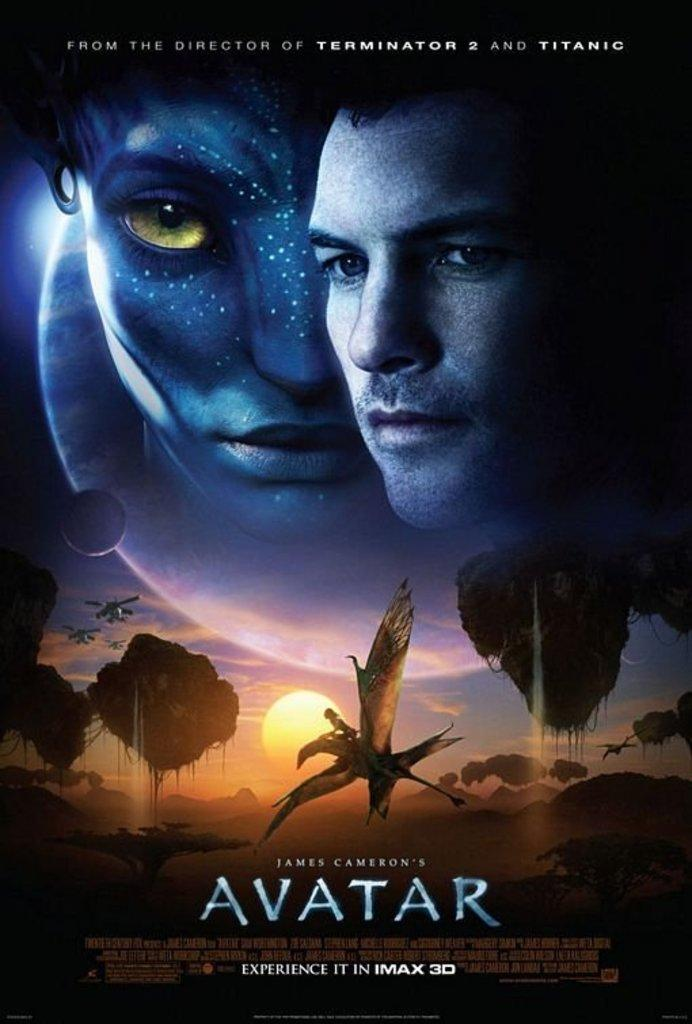<image>
Provide a brief description of the given image. A poster for the movie Avatar states it is a James Cameron film. 